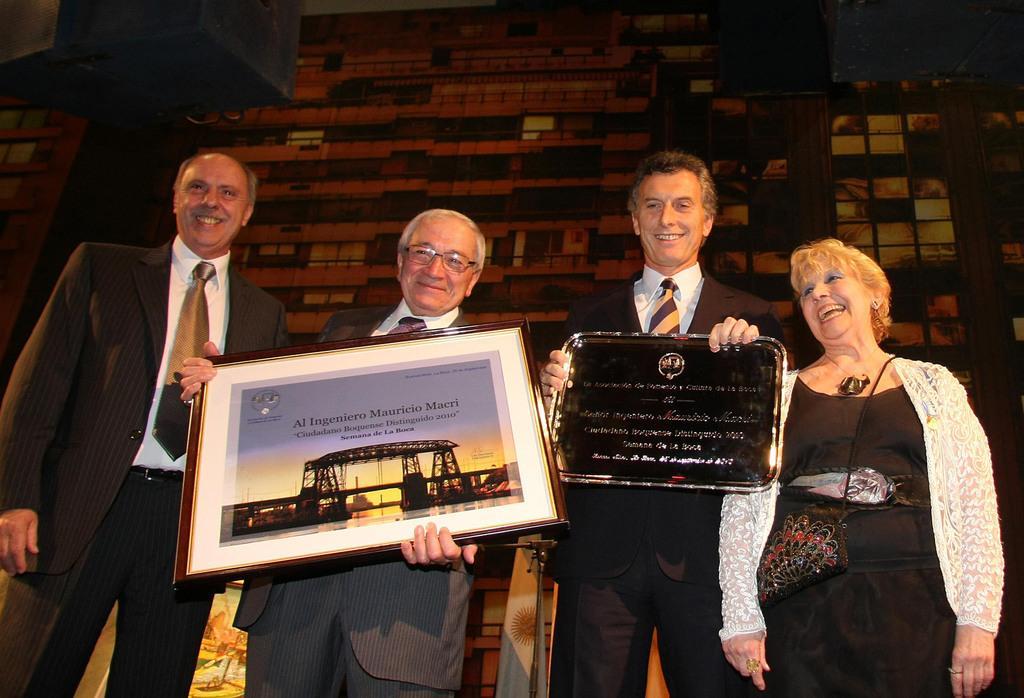In one or two sentences, can you explain what this image depicts? In the center of the image we can see people standing and holding frames in their hands. In the background there is a wall. At the top we can see speakers. 